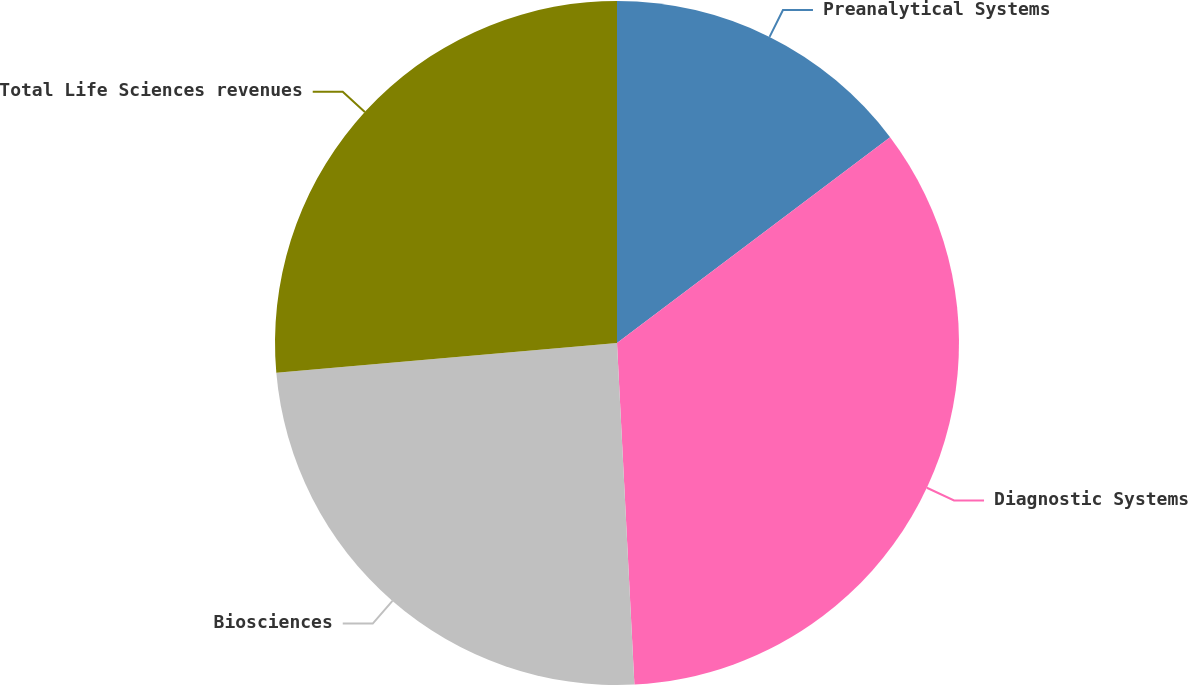<chart> <loc_0><loc_0><loc_500><loc_500><pie_chart><fcel>Preanalytical Systems<fcel>Diagnostic Systems<fcel>Biosciences<fcel>Total Life Sciences revenues<nl><fcel>14.72%<fcel>34.47%<fcel>24.42%<fcel>26.39%<nl></chart> 